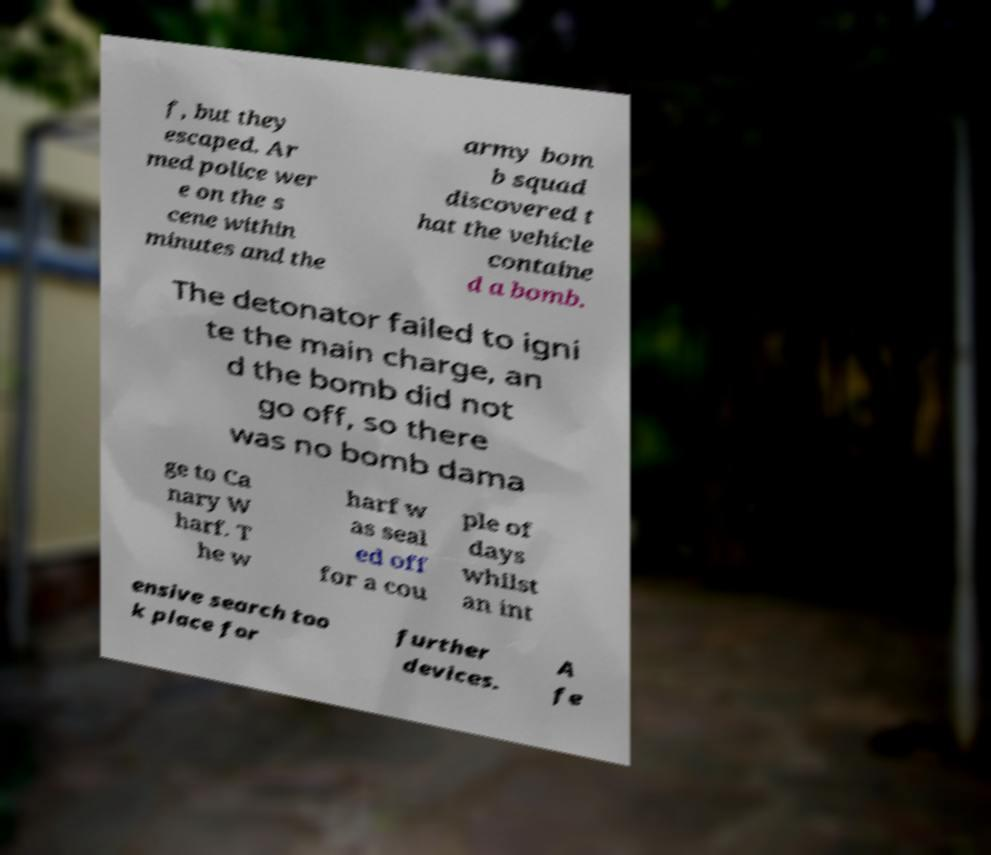Please identify and transcribe the text found in this image. f, but they escaped. Ar med police wer e on the s cene within minutes and the army bom b squad discovered t hat the vehicle containe d a bomb. The detonator failed to igni te the main charge, an d the bomb did not go off, so there was no bomb dama ge to Ca nary W harf. T he w harf w as seal ed off for a cou ple of days whilst an int ensive search too k place for further devices. A fe 